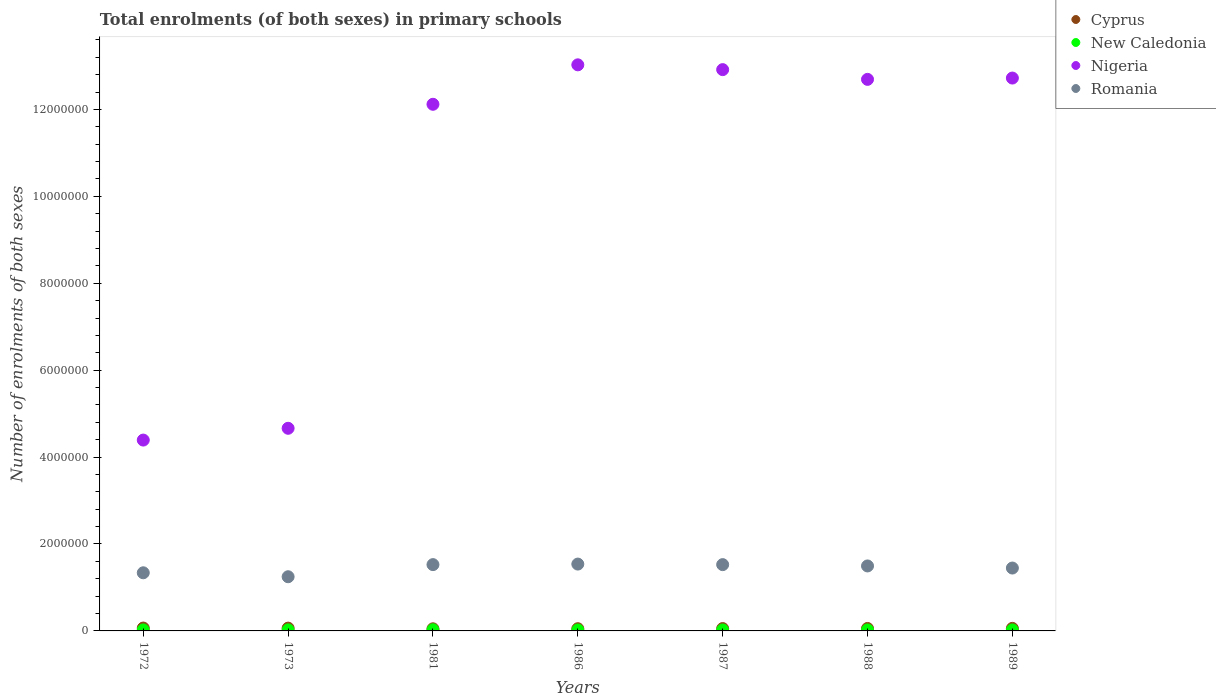How many different coloured dotlines are there?
Offer a terse response. 4. What is the number of enrolments in primary schools in Romania in 1989?
Your answer should be very brief. 1.45e+06. Across all years, what is the maximum number of enrolments in primary schools in Cyprus?
Your answer should be very brief. 6.60e+04. Across all years, what is the minimum number of enrolments in primary schools in New Caledonia?
Provide a succinct answer. 2.22e+04. In which year was the number of enrolments in primary schools in Cyprus maximum?
Make the answer very short. 1972. In which year was the number of enrolments in primary schools in Romania minimum?
Give a very brief answer. 1973. What is the total number of enrolments in primary schools in Nigeria in the graph?
Make the answer very short. 7.25e+07. What is the difference between the number of enrolments in primary schools in New Caledonia in 1981 and that in 1988?
Your response must be concise. 3961. What is the difference between the number of enrolments in primary schools in New Caledonia in 1989 and the number of enrolments in primary schools in Romania in 1987?
Make the answer very short. -1.50e+06. What is the average number of enrolments in primary schools in New Caledonia per year?
Make the answer very short. 2.36e+04. In the year 1986, what is the difference between the number of enrolments in primary schools in Nigeria and number of enrolments in primary schools in Romania?
Make the answer very short. 1.15e+07. What is the ratio of the number of enrolments in primary schools in Nigeria in 1988 to that in 1989?
Offer a very short reply. 1. Is the number of enrolments in primary schools in New Caledonia in 1972 less than that in 1989?
Offer a terse response. No. Is the difference between the number of enrolments in primary schools in Nigeria in 1973 and 1986 greater than the difference between the number of enrolments in primary schools in Romania in 1973 and 1986?
Offer a very short reply. No. What is the difference between the highest and the second highest number of enrolments in primary schools in Romania?
Your answer should be very brief. 1.26e+04. What is the difference between the highest and the lowest number of enrolments in primary schools in Romania?
Ensure brevity in your answer.  2.91e+05. Is it the case that in every year, the sum of the number of enrolments in primary schools in Romania and number of enrolments in primary schools in Nigeria  is greater than the sum of number of enrolments in primary schools in Cyprus and number of enrolments in primary schools in New Caledonia?
Your answer should be compact. Yes. Is the number of enrolments in primary schools in Nigeria strictly greater than the number of enrolments in primary schools in Cyprus over the years?
Offer a terse response. Yes. How many years are there in the graph?
Make the answer very short. 7. What is the difference between two consecutive major ticks on the Y-axis?
Your response must be concise. 2.00e+06. How many legend labels are there?
Your answer should be very brief. 4. How are the legend labels stacked?
Make the answer very short. Vertical. What is the title of the graph?
Your answer should be compact. Total enrolments (of both sexes) in primary schools. Does "Morocco" appear as one of the legend labels in the graph?
Your response must be concise. No. What is the label or title of the X-axis?
Your answer should be compact. Years. What is the label or title of the Y-axis?
Make the answer very short. Number of enrolments of both sexes. What is the Number of enrolments of both sexes in Cyprus in 1972?
Your answer should be compact. 6.60e+04. What is the Number of enrolments of both sexes of New Caledonia in 1972?
Keep it short and to the point. 2.35e+04. What is the Number of enrolments of both sexes in Nigeria in 1972?
Your answer should be very brief. 4.39e+06. What is the Number of enrolments of both sexes in Romania in 1972?
Offer a very short reply. 1.34e+06. What is the Number of enrolments of both sexes in Cyprus in 1973?
Make the answer very short. 6.42e+04. What is the Number of enrolments of both sexes in New Caledonia in 1973?
Ensure brevity in your answer.  2.42e+04. What is the Number of enrolments of both sexes of Nigeria in 1973?
Your answer should be compact. 4.66e+06. What is the Number of enrolments of both sexes in Romania in 1973?
Your response must be concise. 1.25e+06. What is the Number of enrolments of both sexes in Cyprus in 1981?
Provide a short and direct response. 4.87e+04. What is the Number of enrolments of both sexes in New Caledonia in 1981?
Provide a short and direct response. 2.68e+04. What is the Number of enrolments of both sexes in Nigeria in 1981?
Ensure brevity in your answer.  1.21e+07. What is the Number of enrolments of both sexes in Romania in 1981?
Your answer should be very brief. 1.53e+06. What is the Number of enrolments of both sexes in Cyprus in 1986?
Make the answer very short. 5.10e+04. What is the Number of enrolments of both sexes in New Caledonia in 1986?
Your response must be concise. 2.22e+04. What is the Number of enrolments of both sexes in Nigeria in 1986?
Ensure brevity in your answer.  1.30e+07. What is the Number of enrolments of both sexes of Romania in 1986?
Offer a terse response. 1.54e+06. What is the Number of enrolments of both sexes in Cyprus in 1987?
Your answer should be very brief. 5.43e+04. What is the Number of enrolments of both sexes of New Caledonia in 1987?
Ensure brevity in your answer.  2.24e+04. What is the Number of enrolments of both sexes in Nigeria in 1987?
Provide a short and direct response. 1.29e+07. What is the Number of enrolments of both sexes of Romania in 1987?
Provide a succinct answer. 1.53e+06. What is the Number of enrolments of both sexes of Cyprus in 1988?
Ensure brevity in your answer.  5.65e+04. What is the Number of enrolments of both sexes of New Caledonia in 1988?
Provide a succinct answer. 2.28e+04. What is the Number of enrolments of both sexes in Nigeria in 1988?
Your response must be concise. 1.27e+07. What is the Number of enrolments of both sexes of Romania in 1988?
Ensure brevity in your answer.  1.50e+06. What is the Number of enrolments of both sexes of Cyprus in 1989?
Provide a succinct answer. 5.87e+04. What is the Number of enrolments of both sexes in New Caledonia in 1989?
Your answer should be compact. 2.31e+04. What is the Number of enrolments of both sexes in Nigeria in 1989?
Give a very brief answer. 1.27e+07. What is the Number of enrolments of both sexes of Romania in 1989?
Provide a short and direct response. 1.45e+06. Across all years, what is the maximum Number of enrolments of both sexes in Cyprus?
Make the answer very short. 6.60e+04. Across all years, what is the maximum Number of enrolments of both sexes in New Caledonia?
Your answer should be compact. 2.68e+04. Across all years, what is the maximum Number of enrolments of both sexes in Nigeria?
Provide a succinct answer. 1.30e+07. Across all years, what is the maximum Number of enrolments of both sexes of Romania?
Your answer should be very brief. 1.54e+06. Across all years, what is the minimum Number of enrolments of both sexes of Cyprus?
Provide a succinct answer. 4.87e+04. Across all years, what is the minimum Number of enrolments of both sexes in New Caledonia?
Provide a short and direct response. 2.22e+04. Across all years, what is the minimum Number of enrolments of both sexes of Nigeria?
Offer a terse response. 4.39e+06. Across all years, what is the minimum Number of enrolments of both sexes in Romania?
Make the answer very short. 1.25e+06. What is the total Number of enrolments of both sexes of Cyprus in the graph?
Your answer should be compact. 3.99e+05. What is the total Number of enrolments of both sexes in New Caledonia in the graph?
Your answer should be compact. 1.65e+05. What is the total Number of enrolments of both sexes in Nigeria in the graph?
Ensure brevity in your answer.  7.25e+07. What is the total Number of enrolments of both sexes of Romania in the graph?
Your answer should be compact. 1.01e+07. What is the difference between the Number of enrolments of both sexes in Cyprus in 1972 and that in 1973?
Give a very brief answer. 1841. What is the difference between the Number of enrolments of both sexes in New Caledonia in 1972 and that in 1973?
Keep it short and to the point. -753. What is the difference between the Number of enrolments of both sexes in Nigeria in 1972 and that in 1973?
Make the answer very short. -2.71e+05. What is the difference between the Number of enrolments of both sexes in Romania in 1972 and that in 1973?
Provide a succinct answer. 9.09e+04. What is the difference between the Number of enrolments of both sexes of Cyprus in 1972 and that in 1981?
Your answer should be compact. 1.73e+04. What is the difference between the Number of enrolments of both sexes in New Caledonia in 1972 and that in 1981?
Keep it short and to the point. -3312. What is the difference between the Number of enrolments of both sexes of Nigeria in 1972 and that in 1981?
Provide a short and direct response. -7.73e+06. What is the difference between the Number of enrolments of both sexes in Romania in 1972 and that in 1981?
Offer a very short reply. -1.88e+05. What is the difference between the Number of enrolments of both sexes of Cyprus in 1972 and that in 1986?
Your answer should be compact. 1.50e+04. What is the difference between the Number of enrolments of both sexes of New Caledonia in 1972 and that in 1986?
Ensure brevity in your answer.  1230. What is the difference between the Number of enrolments of both sexes of Nigeria in 1972 and that in 1986?
Your response must be concise. -8.63e+06. What is the difference between the Number of enrolments of both sexes in Romania in 1972 and that in 1986?
Give a very brief answer. -2.00e+05. What is the difference between the Number of enrolments of both sexes in Cyprus in 1972 and that in 1987?
Ensure brevity in your answer.  1.18e+04. What is the difference between the Number of enrolments of both sexes of New Caledonia in 1972 and that in 1987?
Your answer should be compact. 1101. What is the difference between the Number of enrolments of both sexes of Nigeria in 1972 and that in 1987?
Keep it short and to the point. -8.52e+06. What is the difference between the Number of enrolments of both sexes of Romania in 1972 and that in 1987?
Your answer should be compact. -1.88e+05. What is the difference between the Number of enrolments of both sexes of Cyprus in 1972 and that in 1988?
Your answer should be very brief. 9497. What is the difference between the Number of enrolments of both sexes in New Caledonia in 1972 and that in 1988?
Your answer should be very brief. 649. What is the difference between the Number of enrolments of both sexes in Nigeria in 1972 and that in 1988?
Make the answer very short. -8.30e+06. What is the difference between the Number of enrolments of both sexes in Romania in 1972 and that in 1988?
Your response must be concise. -1.57e+05. What is the difference between the Number of enrolments of both sexes of Cyprus in 1972 and that in 1989?
Provide a short and direct response. 7307. What is the difference between the Number of enrolments of both sexes in New Caledonia in 1972 and that in 1989?
Your answer should be very brief. 415. What is the difference between the Number of enrolments of both sexes in Nigeria in 1972 and that in 1989?
Give a very brief answer. -8.33e+06. What is the difference between the Number of enrolments of both sexes in Romania in 1972 and that in 1989?
Provide a short and direct response. -1.09e+05. What is the difference between the Number of enrolments of both sexes of Cyprus in 1973 and that in 1981?
Provide a short and direct response. 1.55e+04. What is the difference between the Number of enrolments of both sexes of New Caledonia in 1973 and that in 1981?
Keep it short and to the point. -2559. What is the difference between the Number of enrolments of both sexes in Nigeria in 1973 and that in 1981?
Keep it short and to the point. -7.46e+06. What is the difference between the Number of enrolments of both sexes in Romania in 1973 and that in 1981?
Provide a succinct answer. -2.79e+05. What is the difference between the Number of enrolments of both sexes of Cyprus in 1973 and that in 1986?
Your response must be concise. 1.32e+04. What is the difference between the Number of enrolments of both sexes of New Caledonia in 1973 and that in 1986?
Your answer should be compact. 1983. What is the difference between the Number of enrolments of both sexes in Nigeria in 1973 and that in 1986?
Keep it short and to the point. -8.36e+06. What is the difference between the Number of enrolments of both sexes of Romania in 1973 and that in 1986?
Offer a terse response. -2.91e+05. What is the difference between the Number of enrolments of both sexes in Cyprus in 1973 and that in 1987?
Provide a short and direct response. 9932. What is the difference between the Number of enrolments of both sexes of New Caledonia in 1973 and that in 1987?
Give a very brief answer. 1854. What is the difference between the Number of enrolments of both sexes in Nigeria in 1973 and that in 1987?
Keep it short and to the point. -8.25e+06. What is the difference between the Number of enrolments of both sexes of Romania in 1973 and that in 1987?
Offer a terse response. -2.79e+05. What is the difference between the Number of enrolments of both sexes in Cyprus in 1973 and that in 1988?
Give a very brief answer. 7656. What is the difference between the Number of enrolments of both sexes of New Caledonia in 1973 and that in 1988?
Your answer should be compact. 1402. What is the difference between the Number of enrolments of both sexes in Nigeria in 1973 and that in 1988?
Ensure brevity in your answer.  -8.03e+06. What is the difference between the Number of enrolments of both sexes in Romania in 1973 and that in 1988?
Your response must be concise. -2.48e+05. What is the difference between the Number of enrolments of both sexes of Cyprus in 1973 and that in 1989?
Offer a very short reply. 5466. What is the difference between the Number of enrolments of both sexes in New Caledonia in 1973 and that in 1989?
Provide a short and direct response. 1168. What is the difference between the Number of enrolments of both sexes of Nigeria in 1973 and that in 1989?
Your response must be concise. -8.06e+06. What is the difference between the Number of enrolments of both sexes of Romania in 1973 and that in 1989?
Your response must be concise. -2.00e+05. What is the difference between the Number of enrolments of both sexes of Cyprus in 1981 and that in 1986?
Your answer should be very brief. -2289. What is the difference between the Number of enrolments of both sexes in New Caledonia in 1981 and that in 1986?
Provide a short and direct response. 4542. What is the difference between the Number of enrolments of both sexes of Nigeria in 1981 and that in 1986?
Give a very brief answer. -9.08e+05. What is the difference between the Number of enrolments of both sexes in Romania in 1981 and that in 1986?
Offer a very short reply. -1.26e+04. What is the difference between the Number of enrolments of both sexes in Cyprus in 1981 and that in 1987?
Give a very brief answer. -5553. What is the difference between the Number of enrolments of both sexes in New Caledonia in 1981 and that in 1987?
Your answer should be compact. 4413. What is the difference between the Number of enrolments of both sexes in Nigeria in 1981 and that in 1987?
Your answer should be very brief. -7.97e+05. What is the difference between the Number of enrolments of both sexes in Romania in 1981 and that in 1987?
Your response must be concise. 144. What is the difference between the Number of enrolments of both sexes in Cyprus in 1981 and that in 1988?
Provide a succinct answer. -7829. What is the difference between the Number of enrolments of both sexes of New Caledonia in 1981 and that in 1988?
Your answer should be very brief. 3961. What is the difference between the Number of enrolments of both sexes of Nigeria in 1981 and that in 1988?
Your answer should be compact. -5.73e+05. What is the difference between the Number of enrolments of both sexes of Romania in 1981 and that in 1988?
Offer a terse response. 3.04e+04. What is the difference between the Number of enrolments of both sexes in Cyprus in 1981 and that in 1989?
Make the answer very short. -1.00e+04. What is the difference between the Number of enrolments of both sexes in New Caledonia in 1981 and that in 1989?
Your answer should be compact. 3727. What is the difference between the Number of enrolments of both sexes in Nigeria in 1981 and that in 1989?
Provide a short and direct response. -6.04e+05. What is the difference between the Number of enrolments of both sexes in Romania in 1981 and that in 1989?
Your response must be concise. 7.85e+04. What is the difference between the Number of enrolments of both sexes in Cyprus in 1986 and that in 1987?
Your answer should be compact. -3264. What is the difference between the Number of enrolments of both sexes in New Caledonia in 1986 and that in 1987?
Provide a short and direct response. -129. What is the difference between the Number of enrolments of both sexes in Nigeria in 1986 and that in 1987?
Provide a short and direct response. 1.10e+05. What is the difference between the Number of enrolments of both sexes in Romania in 1986 and that in 1987?
Provide a succinct answer. 1.27e+04. What is the difference between the Number of enrolments of both sexes in Cyprus in 1986 and that in 1988?
Your answer should be very brief. -5540. What is the difference between the Number of enrolments of both sexes in New Caledonia in 1986 and that in 1988?
Provide a succinct answer. -581. What is the difference between the Number of enrolments of both sexes in Nigeria in 1986 and that in 1988?
Your answer should be very brief. 3.34e+05. What is the difference between the Number of enrolments of both sexes of Romania in 1986 and that in 1988?
Your answer should be compact. 4.30e+04. What is the difference between the Number of enrolments of both sexes in Cyprus in 1986 and that in 1989?
Your answer should be compact. -7730. What is the difference between the Number of enrolments of both sexes of New Caledonia in 1986 and that in 1989?
Your answer should be very brief. -815. What is the difference between the Number of enrolments of both sexes in Nigeria in 1986 and that in 1989?
Your answer should be compact. 3.04e+05. What is the difference between the Number of enrolments of both sexes in Romania in 1986 and that in 1989?
Offer a terse response. 9.11e+04. What is the difference between the Number of enrolments of both sexes of Cyprus in 1987 and that in 1988?
Give a very brief answer. -2276. What is the difference between the Number of enrolments of both sexes of New Caledonia in 1987 and that in 1988?
Offer a very short reply. -452. What is the difference between the Number of enrolments of both sexes in Nigeria in 1987 and that in 1988?
Offer a terse response. 2.24e+05. What is the difference between the Number of enrolments of both sexes in Romania in 1987 and that in 1988?
Give a very brief answer. 3.03e+04. What is the difference between the Number of enrolments of both sexes of Cyprus in 1987 and that in 1989?
Provide a short and direct response. -4466. What is the difference between the Number of enrolments of both sexes in New Caledonia in 1987 and that in 1989?
Keep it short and to the point. -686. What is the difference between the Number of enrolments of both sexes in Nigeria in 1987 and that in 1989?
Keep it short and to the point. 1.94e+05. What is the difference between the Number of enrolments of both sexes in Romania in 1987 and that in 1989?
Offer a terse response. 7.84e+04. What is the difference between the Number of enrolments of both sexes of Cyprus in 1988 and that in 1989?
Offer a very short reply. -2190. What is the difference between the Number of enrolments of both sexes of New Caledonia in 1988 and that in 1989?
Make the answer very short. -234. What is the difference between the Number of enrolments of both sexes in Nigeria in 1988 and that in 1989?
Your answer should be compact. -3.03e+04. What is the difference between the Number of enrolments of both sexes in Romania in 1988 and that in 1989?
Make the answer very short. 4.81e+04. What is the difference between the Number of enrolments of both sexes in Cyprus in 1972 and the Number of enrolments of both sexes in New Caledonia in 1973?
Provide a succinct answer. 4.18e+04. What is the difference between the Number of enrolments of both sexes in Cyprus in 1972 and the Number of enrolments of both sexes in Nigeria in 1973?
Provide a short and direct response. -4.60e+06. What is the difference between the Number of enrolments of both sexes in Cyprus in 1972 and the Number of enrolments of both sexes in Romania in 1973?
Your answer should be compact. -1.18e+06. What is the difference between the Number of enrolments of both sexes in New Caledonia in 1972 and the Number of enrolments of both sexes in Nigeria in 1973?
Your answer should be very brief. -4.64e+06. What is the difference between the Number of enrolments of both sexes in New Caledonia in 1972 and the Number of enrolments of both sexes in Romania in 1973?
Offer a very short reply. -1.22e+06. What is the difference between the Number of enrolments of both sexes in Nigeria in 1972 and the Number of enrolments of both sexes in Romania in 1973?
Give a very brief answer. 3.14e+06. What is the difference between the Number of enrolments of both sexes in Cyprus in 1972 and the Number of enrolments of both sexes in New Caledonia in 1981?
Offer a terse response. 3.92e+04. What is the difference between the Number of enrolments of both sexes of Cyprus in 1972 and the Number of enrolments of both sexes of Nigeria in 1981?
Your answer should be compact. -1.21e+07. What is the difference between the Number of enrolments of both sexes in Cyprus in 1972 and the Number of enrolments of both sexes in Romania in 1981?
Keep it short and to the point. -1.46e+06. What is the difference between the Number of enrolments of both sexes in New Caledonia in 1972 and the Number of enrolments of both sexes in Nigeria in 1981?
Provide a short and direct response. -1.21e+07. What is the difference between the Number of enrolments of both sexes of New Caledonia in 1972 and the Number of enrolments of both sexes of Romania in 1981?
Offer a terse response. -1.50e+06. What is the difference between the Number of enrolments of both sexes of Nigeria in 1972 and the Number of enrolments of both sexes of Romania in 1981?
Give a very brief answer. 2.87e+06. What is the difference between the Number of enrolments of both sexes of Cyprus in 1972 and the Number of enrolments of both sexes of New Caledonia in 1986?
Give a very brief answer. 4.38e+04. What is the difference between the Number of enrolments of both sexes of Cyprus in 1972 and the Number of enrolments of both sexes of Nigeria in 1986?
Your answer should be compact. -1.30e+07. What is the difference between the Number of enrolments of both sexes in Cyprus in 1972 and the Number of enrolments of both sexes in Romania in 1986?
Provide a succinct answer. -1.47e+06. What is the difference between the Number of enrolments of both sexes of New Caledonia in 1972 and the Number of enrolments of both sexes of Nigeria in 1986?
Offer a very short reply. -1.30e+07. What is the difference between the Number of enrolments of both sexes in New Caledonia in 1972 and the Number of enrolments of both sexes in Romania in 1986?
Provide a short and direct response. -1.51e+06. What is the difference between the Number of enrolments of both sexes in Nigeria in 1972 and the Number of enrolments of both sexes in Romania in 1986?
Provide a succinct answer. 2.85e+06. What is the difference between the Number of enrolments of both sexes in Cyprus in 1972 and the Number of enrolments of both sexes in New Caledonia in 1987?
Your response must be concise. 4.37e+04. What is the difference between the Number of enrolments of both sexes in Cyprus in 1972 and the Number of enrolments of both sexes in Nigeria in 1987?
Keep it short and to the point. -1.28e+07. What is the difference between the Number of enrolments of both sexes in Cyprus in 1972 and the Number of enrolments of both sexes in Romania in 1987?
Provide a succinct answer. -1.46e+06. What is the difference between the Number of enrolments of both sexes of New Caledonia in 1972 and the Number of enrolments of both sexes of Nigeria in 1987?
Offer a very short reply. -1.29e+07. What is the difference between the Number of enrolments of both sexes in New Caledonia in 1972 and the Number of enrolments of both sexes in Romania in 1987?
Your answer should be compact. -1.50e+06. What is the difference between the Number of enrolments of both sexes in Nigeria in 1972 and the Number of enrolments of both sexes in Romania in 1987?
Make the answer very short. 2.87e+06. What is the difference between the Number of enrolments of both sexes in Cyprus in 1972 and the Number of enrolments of both sexes in New Caledonia in 1988?
Your answer should be very brief. 4.32e+04. What is the difference between the Number of enrolments of both sexes in Cyprus in 1972 and the Number of enrolments of both sexes in Nigeria in 1988?
Your answer should be compact. -1.26e+07. What is the difference between the Number of enrolments of both sexes in Cyprus in 1972 and the Number of enrolments of both sexes in Romania in 1988?
Offer a very short reply. -1.43e+06. What is the difference between the Number of enrolments of both sexes of New Caledonia in 1972 and the Number of enrolments of both sexes of Nigeria in 1988?
Provide a succinct answer. -1.27e+07. What is the difference between the Number of enrolments of both sexes in New Caledonia in 1972 and the Number of enrolments of both sexes in Romania in 1988?
Your answer should be very brief. -1.47e+06. What is the difference between the Number of enrolments of both sexes of Nigeria in 1972 and the Number of enrolments of both sexes of Romania in 1988?
Offer a terse response. 2.90e+06. What is the difference between the Number of enrolments of both sexes of Cyprus in 1972 and the Number of enrolments of both sexes of New Caledonia in 1989?
Keep it short and to the point. 4.30e+04. What is the difference between the Number of enrolments of both sexes of Cyprus in 1972 and the Number of enrolments of both sexes of Nigeria in 1989?
Offer a terse response. -1.27e+07. What is the difference between the Number of enrolments of both sexes in Cyprus in 1972 and the Number of enrolments of both sexes in Romania in 1989?
Keep it short and to the point. -1.38e+06. What is the difference between the Number of enrolments of both sexes in New Caledonia in 1972 and the Number of enrolments of both sexes in Nigeria in 1989?
Make the answer very short. -1.27e+07. What is the difference between the Number of enrolments of both sexes in New Caledonia in 1972 and the Number of enrolments of both sexes in Romania in 1989?
Ensure brevity in your answer.  -1.42e+06. What is the difference between the Number of enrolments of both sexes of Nigeria in 1972 and the Number of enrolments of both sexes of Romania in 1989?
Ensure brevity in your answer.  2.94e+06. What is the difference between the Number of enrolments of both sexes in Cyprus in 1973 and the Number of enrolments of both sexes in New Caledonia in 1981?
Offer a very short reply. 3.74e+04. What is the difference between the Number of enrolments of both sexes of Cyprus in 1973 and the Number of enrolments of both sexes of Nigeria in 1981?
Your answer should be compact. -1.21e+07. What is the difference between the Number of enrolments of both sexes of Cyprus in 1973 and the Number of enrolments of both sexes of Romania in 1981?
Your response must be concise. -1.46e+06. What is the difference between the Number of enrolments of both sexes in New Caledonia in 1973 and the Number of enrolments of both sexes in Nigeria in 1981?
Offer a terse response. -1.21e+07. What is the difference between the Number of enrolments of both sexes in New Caledonia in 1973 and the Number of enrolments of both sexes in Romania in 1981?
Your answer should be compact. -1.50e+06. What is the difference between the Number of enrolments of both sexes of Nigeria in 1973 and the Number of enrolments of both sexes of Romania in 1981?
Give a very brief answer. 3.14e+06. What is the difference between the Number of enrolments of both sexes in Cyprus in 1973 and the Number of enrolments of both sexes in New Caledonia in 1986?
Keep it short and to the point. 4.19e+04. What is the difference between the Number of enrolments of both sexes of Cyprus in 1973 and the Number of enrolments of both sexes of Nigeria in 1986?
Keep it short and to the point. -1.30e+07. What is the difference between the Number of enrolments of both sexes in Cyprus in 1973 and the Number of enrolments of both sexes in Romania in 1986?
Provide a short and direct response. -1.47e+06. What is the difference between the Number of enrolments of both sexes in New Caledonia in 1973 and the Number of enrolments of both sexes in Nigeria in 1986?
Your answer should be very brief. -1.30e+07. What is the difference between the Number of enrolments of both sexes of New Caledonia in 1973 and the Number of enrolments of both sexes of Romania in 1986?
Give a very brief answer. -1.51e+06. What is the difference between the Number of enrolments of both sexes in Nigeria in 1973 and the Number of enrolments of both sexes in Romania in 1986?
Make the answer very short. 3.12e+06. What is the difference between the Number of enrolments of both sexes of Cyprus in 1973 and the Number of enrolments of both sexes of New Caledonia in 1987?
Your answer should be very brief. 4.18e+04. What is the difference between the Number of enrolments of both sexes of Cyprus in 1973 and the Number of enrolments of both sexes of Nigeria in 1987?
Give a very brief answer. -1.29e+07. What is the difference between the Number of enrolments of both sexes in Cyprus in 1973 and the Number of enrolments of both sexes in Romania in 1987?
Make the answer very short. -1.46e+06. What is the difference between the Number of enrolments of both sexes in New Caledonia in 1973 and the Number of enrolments of both sexes in Nigeria in 1987?
Your answer should be very brief. -1.29e+07. What is the difference between the Number of enrolments of both sexes in New Caledonia in 1973 and the Number of enrolments of both sexes in Romania in 1987?
Offer a terse response. -1.50e+06. What is the difference between the Number of enrolments of both sexes of Nigeria in 1973 and the Number of enrolments of both sexes of Romania in 1987?
Provide a short and direct response. 3.14e+06. What is the difference between the Number of enrolments of both sexes of Cyprus in 1973 and the Number of enrolments of both sexes of New Caledonia in 1988?
Provide a short and direct response. 4.14e+04. What is the difference between the Number of enrolments of both sexes of Cyprus in 1973 and the Number of enrolments of both sexes of Nigeria in 1988?
Make the answer very short. -1.26e+07. What is the difference between the Number of enrolments of both sexes of Cyprus in 1973 and the Number of enrolments of both sexes of Romania in 1988?
Your answer should be compact. -1.43e+06. What is the difference between the Number of enrolments of both sexes in New Caledonia in 1973 and the Number of enrolments of both sexes in Nigeria in 1988?
Offer a very short reply. -1.27e+07. What is the difference between the Number of enrolments of both sexes of New Caledonia in 1973 and the Number of enrolments of both sexes of Romania in 1988?
Offer a very short reply. -1.47e+06. What is the difference between the Number of enrolments of both sexes in Nigeria in 1973 and the Number of enrolments of both sexes in Romania in 1988?
Ensure brevity in your answer.  3.17e+06. What is the difference between the Number of enrolments of both sexes of Cyprus in 1973 and the Number of enrolments of both sexes of New Caledonia in 1989?
Your response must be concise. 4.11e+04. What is the difference between the Number of enrolments of both sexes in Cyprus in 1973 and the Number of enrolments of both sexes in Nigeria in 1989?
Ensure brevity in your answer.  -1.27e+07. What is the difference between the Number of enrolments of both sexes in Cyprus in 1973 and the Number of enrolments of both sexes in Romania in 1989?
Provide a short and direct response. -1.38e+06. What is the difference between the Number of enrolments of both sexes of New Caledonia in 1973 and the Number of enrolments of both sexes of Nigeria in 1989?
Make the answer very short. -1.27e+07. What is the difference between the Number of enrolments of both sexes of New Caledonia in 1973 and the Number of enrolments of both sexes of Romania in 1989?
Provide a short and direct response. -1.42e+06. What is the difference between the Number of enrolments of both sexes of Nigeria in 1973 and the Number of enrolments of both sexes of Romania in 1989?
Offer a terse response. 3.22e+06. What is the difference between the Number of enrolments of both sexes of Cyprus in 1981 and the Number of enrolments of both sexes of New Caledonia in 1986?
Provide a short and direct response. 2.65e+04. What is the difference between the Number of enrolments of both sexes of Cyprus in 1981 and the Number of enrolments of both sexes of Nigeria in 1986?
Provide a short and direct response. -1.30e+07. What is the difference between the Number of enrolments of both sexes in Cyprus in 1981 and the Number of enrolments of both sexes in Romania in 1986?
Provide a succinct answer. -1.49e+06. What is the difference between the Number of enrolments of both sexes in New Caledonia in 1981 and the Number of enrolments of both sexes in Nigeria in 1986?
Your answer should be very brief. -1.30e+07. What is the difference between the Number of enrolments of both sexes in New Caledonia in 1981 and the Number of enrolments of both sexes in Romania in 1986?
Ensure brevity in your answer.  -1.51e+06. What is the difference between the Number of enrolments of both sexes of Nigeria in 1981 and the Number of enrolments of both sexes of Romania in 1986?
Your response must be concise. 1.06e+07. What is the difference between the Number of enrolments of both sexes in Cyprus in 1981 and the Number of enrolments of both sexes in New Caledonia in 1987?
Make the answer very short. 2.63e+04. What is the difference between the Number of enrolments of both sexes in Cyprus in 1981 and the Number of enrolments of both sexes in Nigeria in 1987?
Offer a terse response. -1.29e+07. What is the difference between the Number of enrolments of both sexes of Cyprus in 1981 and the Number of enrolments of both sexes of Romania in 1987?
Offer a terse response. -1.48e+06. What is the difference between the Number of enrolments of both sexes of New Caledonia in 1981 and the Number of enrolments of both sexes of Nigeria in 1987?
Give a very brief answer. -1.29e+07. What is the difference between the Number of enrolments of both sexes in New Caledonia in 1981 and the Number of enrolments of both sexes in Romania in 1987?
Your answer should be very brief. -1.50e+06. What is the difference between the Number of enrolments of both sexes of Nigeria in 1981 and the Number of enrolments of both sexes of Romania in 1987?
Provide a short and direct response. 1.06e+07. What is the difference between the Number of enrolments of both sexes of Cyprus in 1981 and the Number of enrolments of both sexes of New Caledonia in 1988?
Your answer should be compact. 2.59e+04. What is the difference between the Number of enrolments of both sexes in Cyprus in 1981 and the Number of enrolments of both sexes in Nigeria in 1988?
Your answer should be compact. -1.26e+07. What is the difference between the Number of enrolments of both sexes in Cyprus in 1981 and the Number of enrolments of both sexes in Romania in 1988?
Keep it short and to the point. -1.45e+06. What is the difference between the Number of enrolments of both sexes of New Caledonia in 1981 and the Number of enrolments of both sexes of Nigeria in 1988?
Keep it short and to the point. -1.27e+07. What is the difference between the Number of enrolments of both sexes in New Caledonia in 1981 and the Number of enrolments of both sexes in Romania in 1988?
Your response must be concise. -1.47e+06. What is the difference between the Number of enrolments of both sexes of Nigeria in 1981 and the Number of enrolments of both sexes of Romania in 1988?
Your response must be concise. 1.06e+07. What is the difference between the Number of enrolments of both sexes of Cyprus in 1981 and the Number of enrolments of both sexes of New Caledonia in 1989?
Provide a succinct answer. 2.56e+04. What is the difference between the Number of enrolments of both sexes in Cyprus in 1981 and the Number of enrolments of both sexes in Nigeria in 1989?
Your answer should be compact. -1.27e+07. What is the difference between the Number of enrolments of both sexes of Cyprus in 1981 and the Number of enrolments of both sexes of Romania in 1989?
Give a very brief answer. -1.40e+06. What is the difference between the Number of enrolments of both sexes in New Caledonia in 1981 and the Number of enrolments of both sexes in Nigeria in 1989?
Offer a terse response. -1.27e+07. What is the difference between the Number of enrolments of both sexes in New Caledonia in 1981 and the Number of enrolments of both sexes in Romania in 1989?
Give a very brief answer. -1.42e+06. What is the difference between the Number of enrolments of both sexes in Nigeria in 1981 and the Number of enrolments of both sexes in Romania in 1989?
Keep it short and to the point. 1.07e+07. What is the difference between the Number of enrolments of both sexes of Cyprus in 1986 and the Number of enrolments of both sexes of New Caledonia in 1987?
Provide a short and direct response. 2.86e+04. What is the difference between the Number of enrolments of both sexes of Cyprus in 1986 and the Number of enrolments of both sexes of Nigeria in 1987?
Offer a terse response. -1.29e+07. What is the difference between the Number of enrolments of both sexes in Cyprus in 1986 and the Number of enrolments of both sexes in Romania in 1987?
Provide a short and direct response. -1.47e+06. What is the difference between the Number of enrolments of both sexes in New Caledonia in 1986 and the Number of enrolments of both sexes in Nigeria in 1987?
Make the answer very short. -1.29e+07. What is the difference between the Number of enrolments of both sexes in New Caledonia in 1986 and the Number of enrolments of both sexes in Romania in 1987?
Your answer should be very brief. -1.50e+06. What is the difference between the Number of enrolments of both sexes of Nigeria in 1986 and the Number of enrolments of both sexes of Romania in 1987?
Your answer should be very brief. 1.15e+07. What is the difference between the Number of enrolments of both sexes of Cyprus in 1986 and the Number of enrolments of both sexes of New Caledonia in 1988?
Offer a very short reply. 2.82e+04. What is the difference between the Number of enrolments of both sexes of Cyprus in 1986 and the Number of enrolments of both sexes of Nigeria in 1988?
Your answer should be compact. -1.26e+07. What is the difference between the Number of enrolments of both sexes in Cyprus in 1986 and the Number of enrolments of both sexes in Romania in 1988?
Your answer should be very brief. -1.44e+06. What is the difference between the Number of enrolments of both sexes of New Caledonia in 1986 and the Number of enrolments of both sexes of Nigeria in 1988?
Offer a terse response. -1.27e+07. What is the difference between the Number of enrolments of both sexes of New Caledonia in 1986 and the Number of enrolments of both sexes of Romania in 1988?
Offer a terse response. -1.47e+06. What is the difference between the Number of enrolments of both sexes of Nigeria in 1986 and the Number of enrolments of both sexes of Romania in 1988?
Make the answer very short. 1.15e+07. What is the difference between the Number of enrolments of both sexes in Cyprus in 1986 and the Number of enrolments of both sexes in New Caledonia in 1989?
Keep it short and to the point. 2.79e+04. What is the difference between the Number of enrolments of both sexes of Cyprus in 1986 and the Number of enrolments of both sexes of Nigeria in 1989?
Provide a succinct answer. -1.27e+07. What is the difference between the Number of enrolments of both sexes of Cyprus in 1986 and the Number of enrolments of both sexes of Romania in 1989?
Provide a short and direct response. -1.40e+06. What is the difference between the Number of enrolments of both sexes in New Caledonia in 1986 and the Number of enrolments of both sexes in Nigeria in 1989?
Make the answer very short. -1.27e+07. What is the difference between the Number of enrolments of both sexes in New Caledonia in 1986 and the Number of enrolments of both sexes in Romania in 1989?
Your answer should be compact. -1.42e+06. What is the difference between the Number of enrolments of both sexes of Nigeria in 1986 and the Number of enrolments of both sexes of Romania in 1989?
Provide a succinct answer. 1.16e+07. What is the difference between the Number of enrolments of both sexes of Cyprus in 1987 and the Number of enrolments of both sexes of New Caledonia in 1988?
Give a very brief answer. 3.14e+04. What is the difference between the Number of enrolments of both sexes of Cyprus in 1987 and the Number of enrolments of both sexes of Nigeria in 1988?
Provide a succinct answer. -1.26e+07. What is the difference between the Number of enrolments of both sexes of Cyprus in 1987 and the Number of enrolments of both sexes of Romania in 1988?
Your response must be concise. -1.44e+06. What is the difference between the Number of enrolments of both sexes in New Caledonia in 1987 and the Number of enrolments of both sexes in Nigeria in 1988?
Offer a very short reply. -1.27e+07. What is the difference between the Number of enrolments of both sexes in New Caledonia in 1987 and the Number of enrolments of both sexes in Romania in 1988?
Give a very brief answer. -1.47e+06. What is the difference between the Number of enrolments of both sexes in Nigeria in 1987 and the Number of enrolments of both sexes in Romania in 1988?
Provide a short and direct response. 1.14e+07. What is the difference between the Number of enrolments of both sexes in Cyprus in 1987 and the Number of enrolments of both sexes in New Caledonia in 1989?
Give a very brief answer. 3.12e+04. What is the difference between the Number of enrolments of both sexes in Cyprus in 1987 and the Number of enrolments of both sexes in Nigeria in 1989?
Your answer should be compact. -1.27e+07. What is the difference between the Number of enrolments of both sexes of Cyprus in 1987 and the Number of enrolments of both sexes of Romania in 1989?
Make the answer very short. -1.39e+06. What is the difference between the Number of enrolments of both sexes of New Caledonia in 1987 and the Number of enrolments of both sexes of Nigeria in 1989?
Your response must be concise. -1.27e+07. What is the difference between the Number of enrolments of both sexes in New Caledonia in 1987 and the Number of enrolments of both sexes in Romania in 1989?
Your answer should be compact. -1.42e+06. What is the difference between the Number of enrolments of both sexes of Nigeria in 1987 and the Number of enrolments of both sexes of Romania in 1989?
Keep it short and to the point. 1.15e+07. What is the difference between the Number of enrolments of both sexes of Cyprus in 1988 and the Number of enrolments of both sexes of New Caledonia in 1989?
Make the answer very short. 3.35e+04. What is the difference between the Number of enrolments of both sexes in Cyprus in 1988 and the Number of enrolments of both sexes in Nigeria in 1989?
Offer a very short reply. -1.27e+07. What is the difference between the Number of enrolments of both sexes of Cyprus in 1988 and the Number of enrolments of both sexes of Romania in 1989?
Offer a terse response. -1.39e+06. What is the difference between the Number of enrolments of both sexes in New Caledonia in 1988 and the Number of enrolments of both sexes in Nigeria in 1989?
Make the answer very short. -1.27e+07. What is the difference between the Number of enrolments of both sexes of New Caledonia in 1988 and the Number of enrolments of both sexes of Romania in 1989?
Make the answer very short. -1.42e+06. What is the difference between the Number of enrolments of both sexes in Nigeria in 1988 and the Number of enrolments of both sexes in Romania in 1989?
Your answer should be very brief. 1.12e+07. What is the average Number of enrolments of both sexes in Cyprus per year?
Your response must be concise. 5.71e+04. What is the average Number of enrolments of both sexes of New Caledonia per year?
Give a very brief answer. 2.36e+04. What is the average Number of enrolments of both sexes of Nigeria per year?
Offer a very short reply. 1.04e+07. What is the average Number of enrolments of both sexes of Romania per year?
Your answer should be compact. 1.44e+06. In the year 1972, what is the difference between the Number of enrolments of both sexes in Cyprus and Number of enrolments of both sexes in New Caledonia?
Your answer should be compact. 4.26e+04. In the year 1972, what is the difference between the Number of enrolments of both sexes in Cyprus and Number of enrolments of both sexes in Nigeria?
Keep it short and to the point. -4.33e+06. In the year 1972, what is the difference between the Number of enrolments of both sexes in Cyprus and Number of enrolments of both sexes in Romania?
Make the answer very short. -1.27e+06. In the year 1972, what is the difference between the Number of enrolments of both sexes of New Caledonia and Number of enrolments of both sexes of Nigeria?
Your answer should be very brief. -4.37e+06. In the year 1972, what is the difference between the Number of enrolments of both sexes in New Caledonia and Number of enrolments of both sexes in Romania?
Your answer should be compact. -1.31e+06. In the year 1972, what is the difference between the Number of enrolments of both sexes in Nigeria and Number of enrolments of both sexes in Romania?
Offer a very short reply. 3.05e+06. In the year 1973, what is the difference between the Number of enrolments of both sexes in Cyprus and Number of enrolments of both sexes in New Caledonia?
Provide a short and direct response. 4.00e+04. In the year 1973, what is the difference between the Number of enrolments of both sexes in Cyprus and Number of enrolments of both sexes in Nigeria?
Your answer should be compact. -4.60e+06. In the year 1973, what is the difference between the Number of enrolments of both sexes of Cyprus and Number of enrolments of both sexes of Romania?
Your answer should be very brief. -1.18e+06. In the year 1973, what is the difference between the Number of enrolments of both sexes of New Caledonia and Number of enrolments of both sexes of Nigeria?
Offer a very short reply. -4.64e+06. In the year 1973, what is the difference between the Number of enrolments of both sexes of New Caledonia and Number of enrolments of both sexes of Romania?
Give a very brief answer. -1.22e+06. In the year 1973, what is the difference between the Number of enrolments of both sexes of Nigeria and Number of enrolments of both sexes of Romania?
Your response must be concise. 3.42e+06. In the year 1981, what is the difference between the Number of enrolments of both sexes in Cyprus and Number of enrolments of both sexes in New Caledonia?
Ensure brevity in your answer.  2.19e+04. In the year 1981, what is the difference between the Number of enrolments of both sexes in Cyprus and Number of enrolments of both sexes in Nigeria?
Your answer should be compact. -1.21e+07. In the year 1981, what is the difference between the Number of enrolments of both sexes in Cyprus and Number of enrolments of both sexes in Romania?
Your answer should be compact. -1.48e+06. In the year 1981, what is the difference between the Number of enrolments of both sexes in New Caledonia and Number of enrolments of both sexes in Nigeria?
Keep it short and to the point. -1.21e+07. In the year 1981, what is the difference between the Number of enrolments of both sexes in New Caledonia and Number of enrolments of both sexes in Romania?
Offer a terse response. -1.50e+06. In the year 1981, what is the difference between the Number of enrolments of both sexes of Nigeria and Number of enrolments of both sexes of Romania?
Give a very brief answer. 1.06e+07. In the year 1986, what is the difference between the Number of enrolments of both sexes of Cyprus and Number of enrolments of both sexes of New Caledonia?
Give a very brief answer. 2.88e+04. In the year 1986, what is the difference between the Number of enrolments of both sexes in Cyprus and Number of enrolments of both sexes in Nigeria?
Provide a succinct answer. -1.30e+07. In the year 1986, what is the difference between the Number of enrolments of both sexes in Cyprus and Number of enrolments of both sexes in Romania?
Your answer should be very brief. -1.49e+06. In the year 1986, what is the difference between the Number of enrolments of both sexes in New Caledonia and Number of enrolments of both sexes in Nigeria?
Your answer should be very brief. -1.30e+07. In the year 1986, what is the difference between the Number of enrolments of both sexes of New Caledonia and Number of enrolments of both sexes of Romania?
Provide a succinct answer. -1.52e+06. In the year 1986, what is the difference between the Number of enrolments of both sexes of Nigeria and Number of enrolments of both sexes of Romania?
Make the answer very short. 1.15e+07. In the year 1987, what is the difference between the Number of enrolments of both sexes of Cyprus and Number of enrolments of both sexes of New Caledonia?
Give a very brief answer. 3.19e+04. In the year 1987, what is the difference between the Number of enrolments of both sexes of Cyprus and Number of enrolments of both sexes of Nigeria?
Give a very brief answer. -1.29e+07. In the year 1987, what is the difference between the Number of enrolments of both sexes in Cyprus and Number of enrolments of both sexes in Romania?
Give a very brief answer. -1.47e+06. In the year 1987, what is the difference between the Number of enrolments of both sexes of New Caledonia and Number of enrolments of both sexes of Nigeria?
Offer a very short reply. -1.29e+07. In the year 1987, what is the difference between the Number of enrolments of both sexes of New Caledonia and Number of enrolments of both sexes of Romania?
Provide a succinct answer. -1.50e+06. In the year 1987, what is the difference between the Number of enrolments of both sexes of Nigeria and Number of enrolments of both sexes of Romania?
Offer a very short reply. 1.14e+07. In the year 1988, what is the difference between the Number of enrolments of both sexes in Cyprus and Number of enrolments of both sexes in New Caledonia?
Provide a short and direct response. 3.37e+04. In the year 1988, what is the difference between the Number of enrolments of both sexes in Cyprus and Number of enrolments of both sexes in Nigeria?
Provide a short and direct response. -1.26e+07. In the year 1988, what is the difference between the Number of enrolments of both sexes in Cyprus and Number of enrolments of both sexes in Romania?
Offer a terse response. -1.44e+06. In the year 1988, what is the difference between the Number of enrolments of both sexes of New Caledonia and Number of enrolments of both sexes of Nigeria?
Ensure brevity in your answer.  -1.27e+07. In the year 1988, what is the difference between the Number of enrolments of both sexes of New Caledonia and Number of enrolments of both sexes of Romania?
Ensure brevity in your answer.  -1.47e+06. In the year 1988, what is the difference between the Number of enrolments of both sexes of Nigeria and Number of enrolments of both sexes of Romania?
Offer a terse response. 1.12e+07. In the year 1989, what is the difference between the Number of enrolments of both sexes of Cyprus and Number of enrolments of both sexes of New Caledonia?
Provide a short and direct response. 3.57e+04. In the year 1989, what is the difference between the Number of enrolments of both sexes of Cyprus and Number of enrolments of both sexes of Nigeria?
Make the answer very short. -1.27e+07. In the year 1989, what is the difference between the Number of enrolments of both sexes of Cyprus and Number of enrolments of both sexes of Romania?
Offer a terse response. -1.39e+06. In the year 1989, what is the difference between the Number of enrolments of both sexes in New Caledonia and Number of enrolments of both sexes in Nigeria?
Your answer should be very brief. -1.27e+07. In the year 1989, what is the difference between the Number of enrolments of both sexes in New Caledonia and Number of enrolments of both sexes in Romania?
Provide a succinct answer. -1.42e+06. In the year 1989, what is the difference between the Number of enrolments of both sexes of Nigeria and Number of enrolments of both sexes of Romania?
Your answer should be very brief. 1.13e+07. What is the ratio of the Number of enrolments of both sexes in Cyprus in 1972 to that in 1973?
Your answer should be very brief. 1.03. What is the ratio of the Number of enrolments of both sexes of New Caledonia in 1972 to that in 1973?
Keep it short and to the point. 0.97. What is the ratio of the Number of enrolments of both sexes in Nigeria in 1972 to that in 1973?
Make the answer very short. 0.94. What is the ratio of the Number of enrolments of both sexes in Romania in 1972 to that in 1973?
Offer a very short reply. 1.07. What is the ratio of the Number of enrolments of both sexes in Cyprus in 1972 to that in 1981?
Offer a very short reply. 1.36. What is the ratio of the Number of enrolments of both sexes of New Caledonia in 1972 to that in 1981?
Offer a very short reply. 0.88. What is the ratio of the Number of enrolments of both sexes in Nigeria in 1972 to that in 1981?
Provide a short and direct response. 0.36. What is the ratio of the Number of enrolments of both sexes of Romania in 1972 to that in 1981?
Your answer should be very brief. 0.88. What is the ratio of the Number of enrolments of both sexes in Cyprus in 1972 to that in 1986?
Keep it short and to the point. 1.29. What is the ratio of the Number of enrolments of both sexes in New Caledonia in 1972 to that in 1986?
Offer a very short reply. 1.06. What is the ratio of the Number of enrolments of both sexes of Nigeria in 1972 to that in 1986?
Your answer should be compact. 0.34. What is the ratio of the Number of enrolments of both sexes in Romania in 1972 to that in 1986?
Your answer should be compact. 0.87. What is the ratio of the Number of enrolments of both sexes of Cyprus in 1972 to that in 1987?
Your response must be concise. 1.22. What is the ratio of the Number of enrolments of both sexes of New Caledonia in 1972 to that in 1987?
Provide a succinct answer. 1.05. What is the ratio of the Number of enrolments of both sexes of Nigeria in 1972 to that in 1987?
Offer a very short reply. 0.34. What is the ratio of the Number of enrolments of both sexes of Romania in 1972 to that in 1987?
Provide a succinct answer. 0.88. What is the ratio of the Number of enrolments of both sexes of Cyprus in 1972 to that in 1988?
Your answer should be very brief. 1.17. What is the ratio of the Number of enrolments of both sexes in New Caledonia in 1972 to that in 1988?
Your answer should be compact. 1.03. What is the ratio of the Number of enrolments of both sexes of Nigeria in 1972 to that in 1988?
Provide a succinct answer. 0.35. What is the ratio of the Number of enrolments of both sexes in Romania in 1972 to that in 1988?
Keep it short and to the point. 0.89. What is the ratio of the Number of enrolments of both sexes in Cyprus in 1972 to that in 1989?
Offer a very short reply. 1.12. What is the ratio of the Number of enrolments of both sexes of New Caledonia in 1972 to that in 1989?
Make the answer very short. 1.02. What is the ratio of the Number of enrolments of both sexes of Nigeria in 1972 to that in 1989?
Your answer should be very brief. 0.35. What is the ratio of the Number of enrolments of both sexes of Romania in 1972 to that in 1989?
Provide a short and direct response. 0.92. What is the ratio of the Number of enrolments of both sexes of Cyprus in 1973 to that in 1981?
Ensure brevity in your answer.  1.32. What is the ratio of the Number of enrolments of both sexes in New Caledonia in 1973 to that in 1981?
Offer a terse response. 0.9. What is the ratio of the Number of enrolments of both sexes in Nigeria in 1973 to that in 1981?
Offer a very short reply. 0.38. What is the ratio of the Number of enrolments of both sexes of Romania in 1973 to that in 1981?
Offer a very short reply. 0.82. What is the ratio of the Number of enrolments of both sexes of Cyprus in 1973 to that in 1986?
Your answer should be very brief. 1.26. What is the ratio of the Number of enrolments of both sexes in New Caledonia in 1973 to that in 1986?
Make the answer very short. 1.09. What is the ratio of the Number of enrolments of both sexes of Nigeria in 1973 to that in 1986?
Offer a very short reply. 0.36. What is the ratio of the Number of enrolments of both sexes of Romania in 1973 to that in 1986?
Provide a succinct answer. 0.81. What is the ratio of the Number of enrolments of both sexes of Cyprus in 1973 to that in 1987?
Your answer should be very brief. 1.18. What is the ratio of the Number of enrolments of both sexes in New Caledonia in 1973 to that in 1987?
Offer a very short reply. 1.08. What is the ratio of the Number of enrolments of both sexes in Nigeria in 1973 to that in 1987?
Your answer should be very brief. 0.36. What is the ratio of the Number of enrolments of both sexes of Romania in 1973 to that in 1987?
Give a very brief answer. 0.82. What is the ratio of the Number of enrolments of both sexes of Cyprus in 1973 to that in 1988?
Make the answer very short. 1.14. What is the ratio of the Number of enrolments of both sexes in New Caledonia in 1973 to that in 1988?
Offer a terse response. 1.06. What is the ratio of the Number of enrolments of both sexes of Nigeria in 1973 to that in 1988?
Provide a succinct answer. 0.37. What is the ratio of the Number of enrolments of both sexes in Romania in 1973 to that in 1988?
Your response must be concise. 0.83. What is the ratio of the Number of enrolments of both sexes in Cyprus in 1973 to that in 1989?
Make the answer very short. 1.09. What is the ratio of the Number of enrolments of both sexes of New Caledonia in 1973 to that in 1989?
Your response must be concise. 1.05. What is the ratio of the Number of enrolments of both sexes of Nigeria in 1973 to that in 1989?
Make the answer very short. 0.37. What is the ratio of the Number of enrolments of both sexes in Romania in 1973 to that in 1989?
Keep it short and to the point. 0.86. What is the ratio of the Number of enrolments of both sexes in Cyprus in 1981 to that in 1986?
Provide a succinct answer. 0.96. What is the ratio of the Number of enrolments of both sexes in New Caledonia in 1981 to that in 1986?
Make the answer very short. 1.2. What is the ratio of the Number of enrolments of both sexes in Nigeria in 1981 to that in 1986?
Provide a short and direct response. 0.93. What is the ratio of the Number of enrolments of both sexes of Romania in 1981 to that in 1986?
Your answer should be compact. 0.99. What is the ratio of the Number of enrolments of both sexes in Cyprus in 1981 to that in 1987?
Make the answer very short. 0.9. What is the ratio of the Number of enrolments of both sexes of New Caledonia in 1981 to that in 1987?
Offer a very short reply. 1.2. What is the ratio of the Number of enrolments of both sexes of Nigeria in 1981 to that in 1987?
Provide a short and direct response. 0.94. What is the ratio of the Number of enrolments of both sexes in Cyprus in 1981 to that in 1988?
Offer a terse response. 0.86. What is the ratio of the Number of enrolments of both sexes in New Caledonia in 1981 to that in 1988?
Offer a terse response. 1.17. What is the ratio of the Number of enrolments of both sexes in Nigeria in 1981 to that in 1988?
Make the answer very short. 0.95. What is the ratio of the Number of enrolments of both sexes in Romania in 1981 to that in 1988?
Keep it short and to the point. 1.02. What is the ratio of the Number of enrolments of both sexes in Cyprus in 1981 to that in 1989?
Offer a terse response. 0.83. What is the ratio of the Number of enrolments of both sexes in New Caledonia in 1981 to that in 1989?
Keep it short and to the point. 1.16. What is the ratio of the Number of enrolments of both sexes of Nigeria in 1981 to that in 1989?
Your response must be concise. 0.95. What is the ratio of the Number of enrolments of both sexes in Romania in 1981 to that in 1989?
Your answer should be very brief. 1.05. What is the ratio of the Number of enrolments of both sexes of Cyprus in 1986 to that in 1987?
Make the answer very short. 0.94. What is the ratio of the Number of enrolments of both sexes of Nigeria in 1986 to that in 1987?
Keep it short and to the point. 1.01. What is the ratio of the Number of enrolments of both sexes in Romania in 1986 to that in 1987?
Provide a short and direct response. 1.01. What is the ratio of the Number of enrolments of both sexes of Cyprus in 1986 to that in 1988?
Provide a short and direct response. 0.9. What is the ratio of the Number of enrolments of both sexes in New Caledonia in 1986 to that in 1988?
Provide a succinct answer. 0.97. What is the ratio of the Number of enrolments of both sexes of Nigeria in 1986 to that in 1988?
Provide a succinct answer. 1.03. What is the ratio of the Number of enrolments of both sexes of Romania in 1986 to that in 1988?
Provide a short and direct response. 1.03. What is the ratio of the Number of enrolments of both sexes of Cyprus in 1986 to that in 1989?
Your response must be concise. 0.87. What is the ratio of the Number of enrolments of both sexes of New Caledonia in 1986 to that in 1989?
Your answer should be compact. 0.96. What is the ratio of the Number of enrolments of both sexes of Nigeria in 1986 to that in 1989?
Your answer should be very brief. 1.02. What is the ratio of the Number of enrolments of both sexes in Romania in 1986 to that in 1989?
Offer a terse response. 1.06. What is the ratio of the Number of enrolments of both sexes of Cyprus in 1987 to that in 1988?
Your answer should be compact. 0.96. What is the ratio of the Number of enrolments of both sexes in New Caledonia in 1987 to that in 1988?
Provide a short and direct response. 0.98. What is the ratio of the Number of enrolments of both sexes of Nigeria in 1987 to that in 1988?
Offer a terse response. 1.02. What is the ratio of the Number of enrolments of both sexes in Romania in 1987 to that in 1988?
Provide a short and direct response. 1.02. What is the ratio of the Number of enrolments of both sexes in Cyprus in 1987 to that in 1989?
Your answer should be very brief. 0.92. What is the ratio of the Number of enrolments of both sexes in New Caledonia in 1987 to that in 1989?
Provide a short and direct response. 0.97. What is the ratio of the Number of enrolments of both sexes of Nigeria in 1987 to that in 1989?
Provide a succinct answer. 1.02. What is the ratio of the Number of enrolments of both sexes in Romania in 1987 to that in 1989?
Your answer should be compact. 1.05. What is the ratio of the Number of enrolments of both sexes of Cyprus in 1988 to that in 1989?
Make the answer very short. 0.96. What is the ratio of the Number of enrolments of both sexes of Romania in 1988 to that in 1989?
Your answer should be compact. 1.03. What is the difference between the highest and the second highest Number of enrolments of both sexes in Cyprus?
Your answer should be very brief. 1841. What is the difference between the highest and the second highest Number of enrolments of both sexes of New Caledonia?
Your response must be concise. 2559. What is the difference between the highest and the second highest Number of enrolments of both sexes in Nigeria?
Provide a short and direct response. 1.10e+05. What is the difference between the highest and the second highest Number of enrolments of both sexes of Romania?
Your answer should be very brief. 1.26e+04. What is the difference between the highest and the lowest Number of enrolments of both sexes in Cyprus?
Give a very brief answer. 1.73e+04. What is the difference between the highest and the lowest Number of enrolments of both sexes in New Caledonia?
Your answer should be very brief. 4542. What is the difference between the highest and the lowest Number of enrolments of both sexes in Nigeria?
Offer a very short reply. 8.63e+06. What is the difference between the highest and the lowest Number of enrolments of both sexes in Romania?
Ensure brevity in your answer.  2.91e+05. 